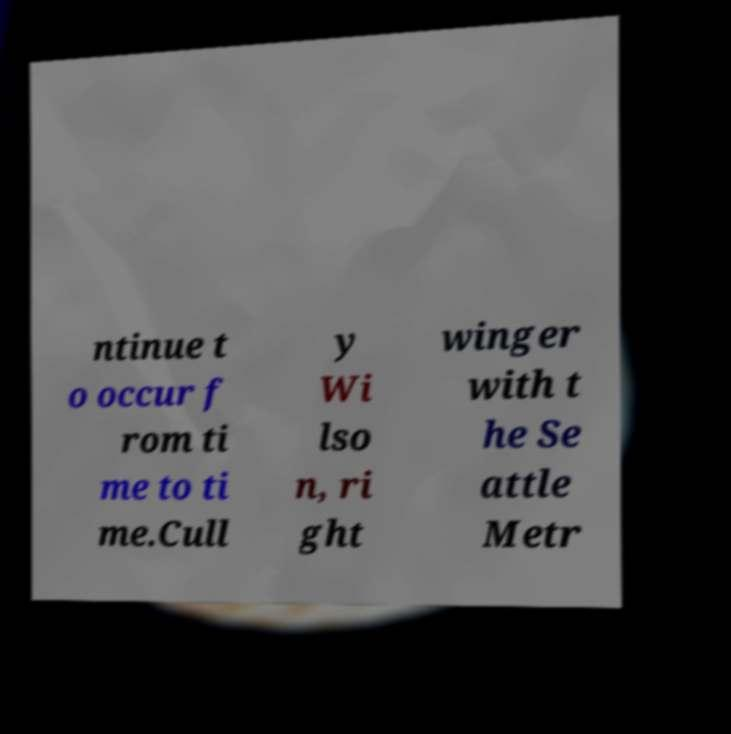Can you read and provide the text displayed in the image?This photo seems to have some interesting text. Can you extract and type it out for me? ntinue t o occur f rom ti me to ti me.Cull y Wi lso n, ri ght winger with t he Se attle Metr 